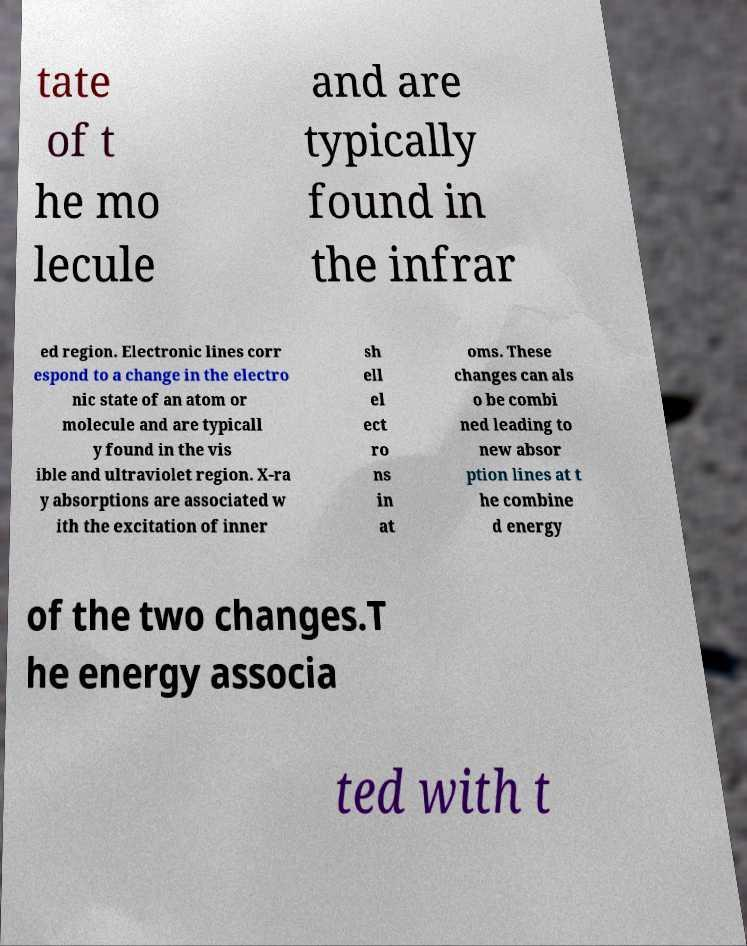I need the written content from this picture converted into text. Can you do that? tate of t he mo lecule and are typically found in the infrar ed region. Electronic lines corr espond to a change in the electro nic state of an atom or molecule and are typicall y found in the vis ible and ultraviolet region. X-ra y absorptions are associated w ith the excitation of inner sh ell el ect ro ns in at oms. These changes can als o be combi ned leading to new absor ption lines at t he combine d energy of the two changes.T he energy associa ted with t 